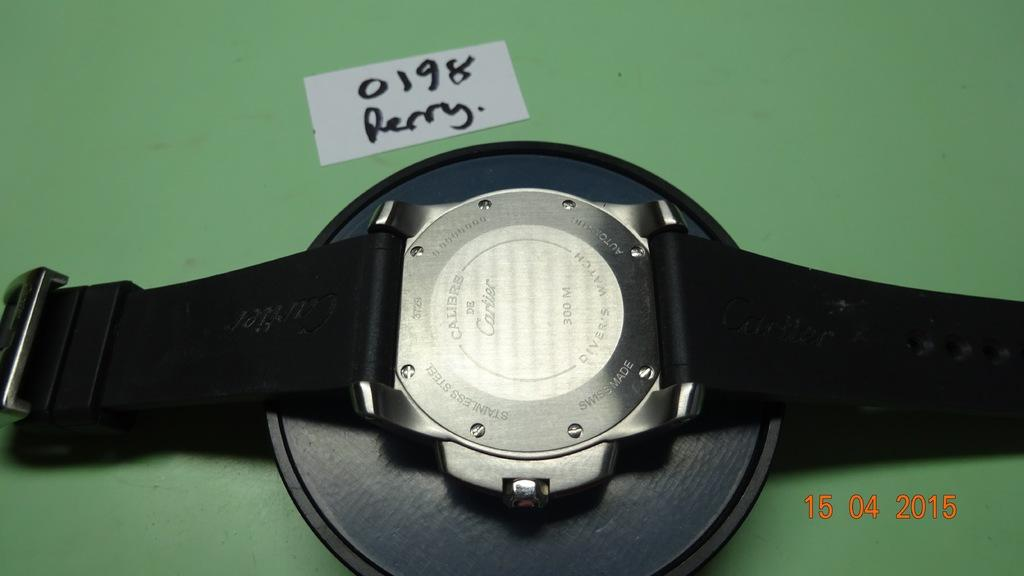Provide a one-sentence caption for the provided image. The back of a Cartier watch says that it is for divers. 